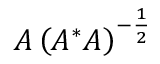<formula> <loc_0><loc_0><loc_500><loc_500>A \left ( A ^ { * } A \right ) ^ { - { \frac { 1 } { 2 } } }</formula> 